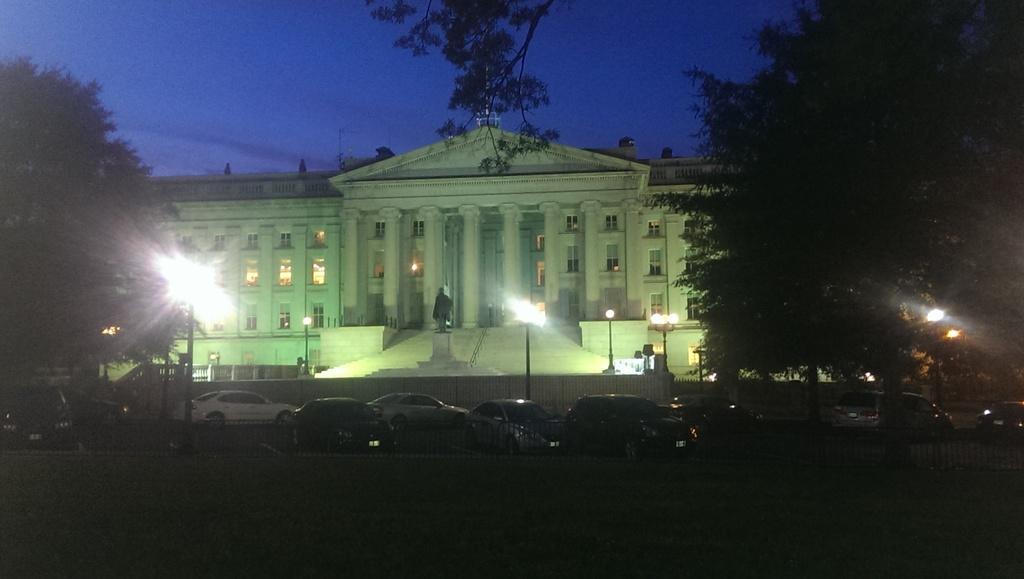Can you describe this image briefly? This image is taken outdoors. At the top of the image there is the sky. At the bottom of the image there is a ground. In the middle of the image many cars are parked on the road and there is a railing. There is a building with walls, windows, pillars, doors and a roof. There are a few stairs and there are a few poles with street lights. On the left and right sides of the image there are two trees. 